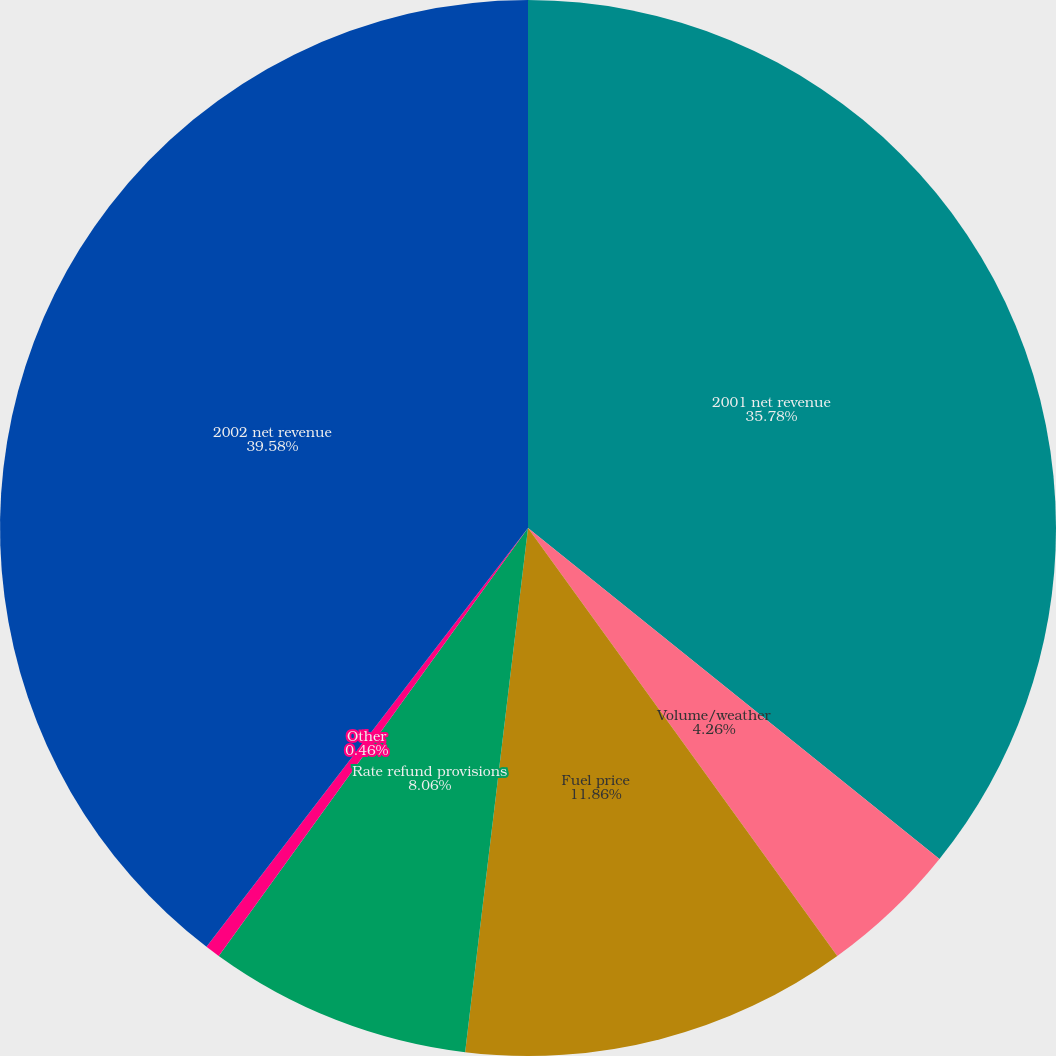Convert chart. <chart><loc_0><loc_0><loc_500><loc_500><pie_chart><fcel>2001 net revenue<fcel>Volume/weather<fcel>Fuel price<fcel>Rate refund provisions<fcel>Other<fcel>2002 net revenue<nl><fcel>35.78%<fcel>4.26%<fcel>11.86%<fcel>8.06%<fcel>0.46%<fcel>39.58%<nl></chart> 